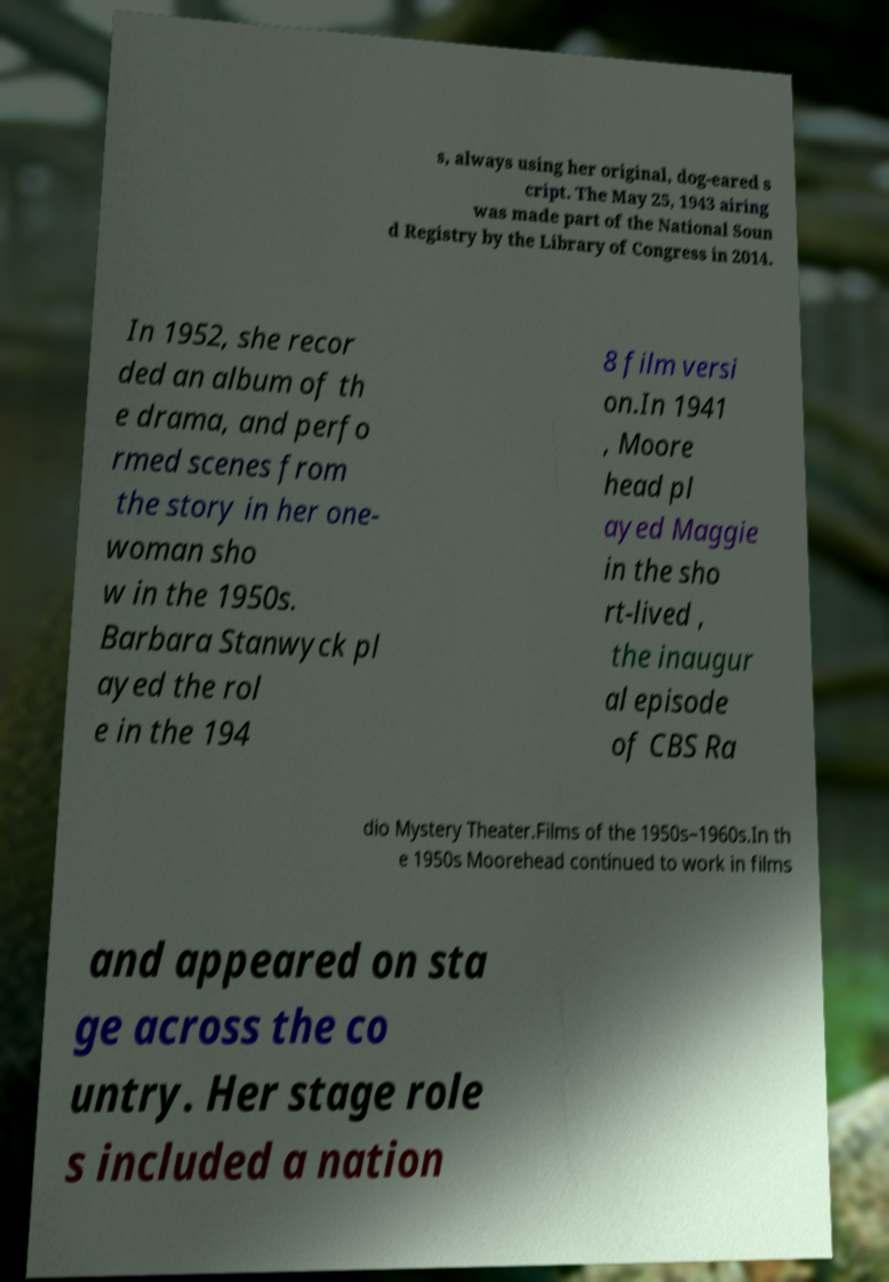I need the written content from this picture converted into text. Can you do that? s, always using her original, dog-eared s cript. The May 25, 1943 airing was made part of the National Soun d Registry by the Library of Congress in 2014. In 1952, she recor ded an album of th e drama, and perfo rmed scenes from the story in her one- woman sho w in the 1950s. Barbara Stanwyck pl ayed the rol e in the 194 8 film versi on.In 1941 , Moore head pl ayed Maggie in the sho rt-lived , the inaugur al episode of CBS Ra dio Mystery Theater.Films of the 1950s–1960s.In th e 1950s Moorehead continued to work in films and appeared on sta ge across the co untry. Her stage role s included a nation 